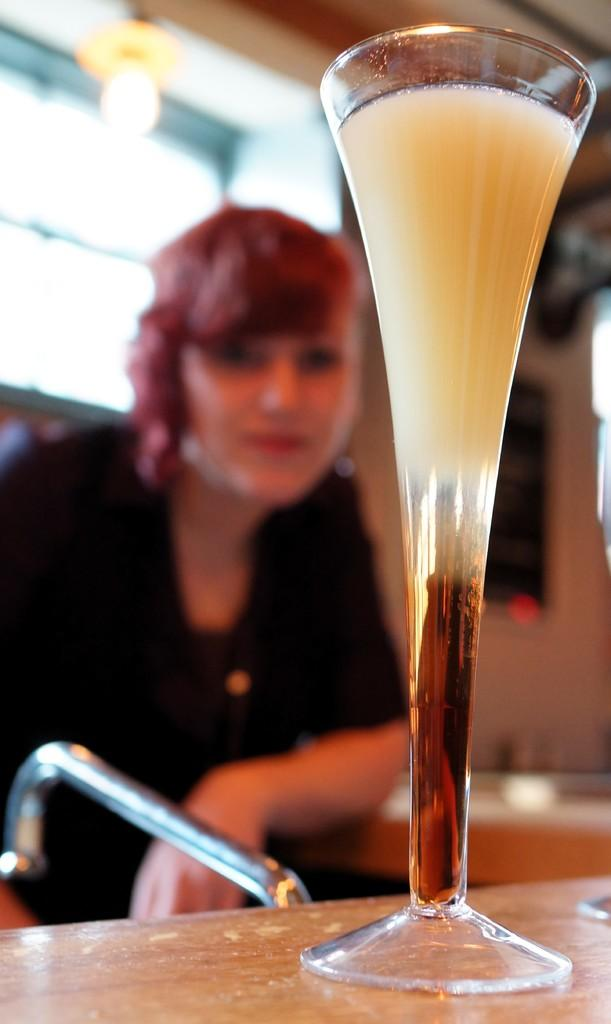What is the person in the image doing? The person is sitting on a seating stool. What is in front of the person? There is a table in front of the person. What can be seen on the table? There is a beverage glass on the table. What type of pies can be seen on the bridge in the image? There is no bridge or pies present in the image. 